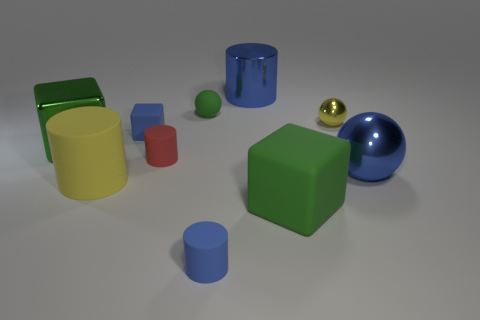There is a big cube that is behind the metallic thing that is in front of the rubber cylinder behind the yellow rubber cylinder; what color is it?
Your answer should be very brief. Green. What color is the other matte object that is the same shape as the small yellow object?
Your answer should be very brief. Green. Are there the same number of large yellow cylinders right of the blue shiny cylinder and metal cylinders?
Make the answer very short. No. What number of balls are blue shiny objects or green metal objects?
Make the answer very short. 1. What is the color of the big cube that is made of the same material as the big blue cylinder?
Give a very brief answer. Green. Do the red thing and the blue cylinder that is in front of the tiny yellow metallic sphere have the same material?
Make the answer very short. Yes. What number of objects are either green metal objects or blue objects?
Give a very brief answer. 5. What material is the large object that is the same color as the tiny shiny object?
Make the answer very short. Rubber. Are there any gray metal objects of the same shape as the small green matte thing?
Ensure brevity in your answer.  No. There is a red matte thing; what number of tiny objects are behind it?
Your answer should be compact. 3. 